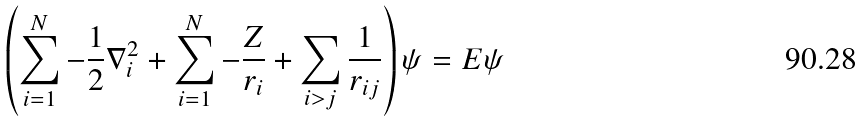Convert formula to latex. <formula><loc_0><loc_0><loc_500><loc_500>\left ( \sum _ { i = 1 } ^ { N } - \frac { 1 } { 2 } \nabla _ { i } ^ { 2 } + \sum _ { i = 1 } ^ { N } - \frac { Z } { r _ { i } } + \sum _ { i > j } \frac { 1 } { r _ { i j } } \right ) \psi = E \psi</formula> 